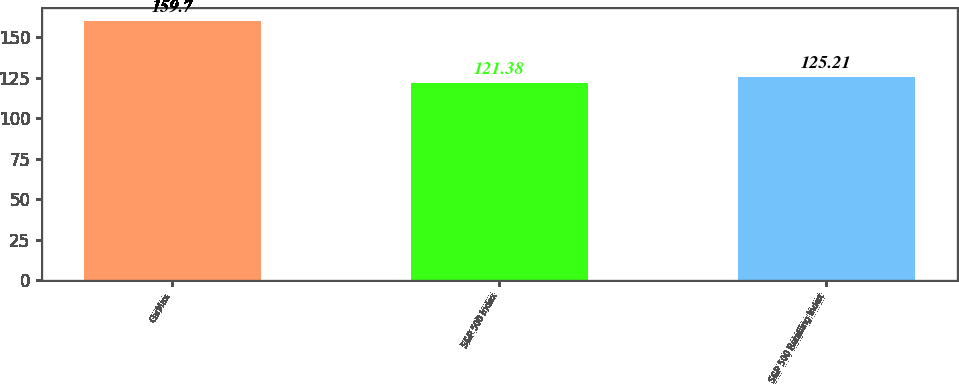<chart> <loc_0><loc_0><loc_500><loc_500><bar_chart><fcel>CarMax<fcel>S&P 500 Index<fcel>S&P 500 Retailing Index<nl><fcel>159.7<fcel>121.38<fcel>125.21<nl></chart> 